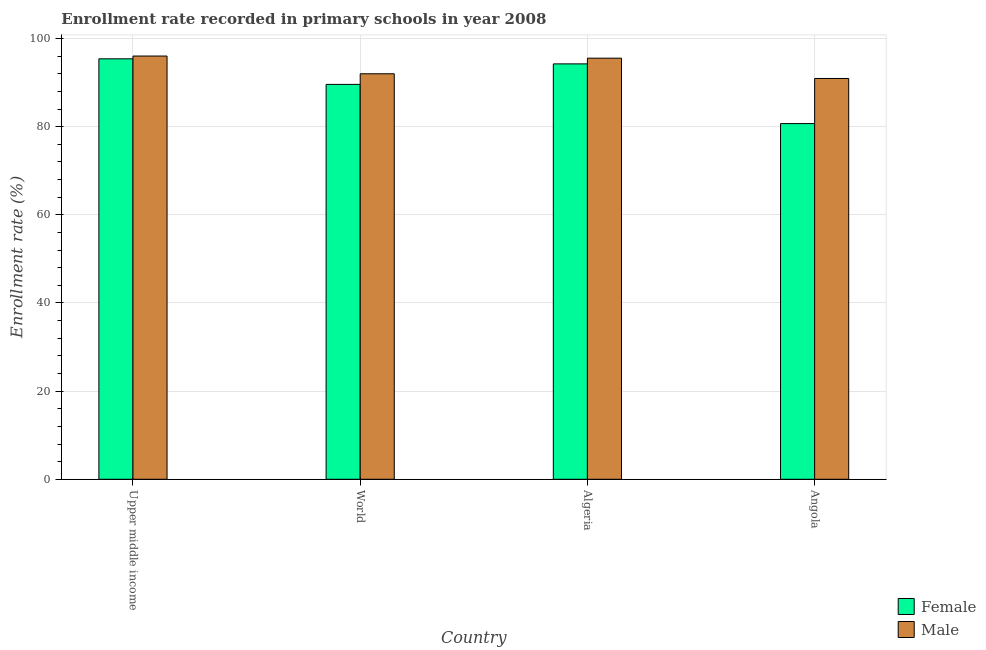How many different coloured bars are there?
Ensure brevity in your answer.  2. How many bars are there on the 2nd tick from the right?
Offer a very short reply. 2. What is the label of the 4th group of bars from the left?
Your response must be concise. Angola. In how many cases, is the number of bars for a given country not equal to the number of legend labels?
Make the answer very short. 0. What is the enrollment rate of male students in Upper middle income?
Your answer should be compact. 96.03. Across all countries, what is the maximum enrollment rate of male students?
Offer a terse response. 96.03. Across all countries, what is the minimum enrollment rate of male students?
Your response must be concise. 90.94. In which country was the enrollment rate of male students maximum?
Provide a short and direct response. Upper middle income. In which country was the enrollment rate of male students minimum?
Provide a short and direct response. Angola. What is the total enrollment rate of male students in the graph?
Offer a terse response. 374.51. What is the difference between the enrollment rate of male students in Algeria and that in World?
Keep it short and to the point. 3.54. What is the difference between the enrollment rate of male students in Algeria and the enrollment rate of female students in World?
Give a very brief answer. 5.95. What is the average enrollment rate of female students per country?
Keep it short and to the point. 89.98. What is the difference between the enrollment rate of male students and enrollment rate of female students in Algeria?
Your answer should be very brief. 1.3. In how many countries, is the enrollment rate of male students greater than 40 %?
Make the answer very short. 4. What is the ratio of the enrollment rate of male students in Algeria to that in World?
Your answer should be very brief. 1.04. Is the difference between the enrollment rate of female students in Algeria and Angola greater than the difference between the enrollment rate of male students in Algeria and Angola?
Offer a terse response. Yes. What is the difference between the highest and the second highest enrollment rate of male students?
Your response must be concise. 0.48. What is the difference between the highest and the lowest enrollment rate of female students?
Your response must be concise. 14.7. Is the sum of the enrollment rate of female students in Algeria and Angola greater than the maximum enrollment rate of male students across all countries?
Keep it short and to the point. Yes. What does the 2nd bar from the right in Angola represents?
Ensure brevity in your answer.  Female. Are all the bars in the graph horizontal?
Ensure brevity in your answer.  No. What is the difference between two consecutive major ticks on the Y-axis?
Provide a short and direct response. 20. Does the graph contain grids?
Give a very brief answer. Yes. How many legend labels are there?
Keep it short and to the point. 2. How are the legend labels stacked?
Ensure brevity in your answer.  Vertical. What is the title of the graph?
Provide a short and direct response. Enrollment rate recorded in primary schools in year 2008. What is the label or title of the Y-axis?
Provide a short and direct response. Enrollment rate (%). What is the Enrollment rate (%) of Female in Upper middle income?
Offer a terse response. 95.4. What is the Enrollment rate (%) in Male in Upper middle income?
Provide a succinct answer. 96.03. What is the Enrollment rate (%) of Female in World?
Your answer should be compact. 89.59. What is the Enrollment rate (%) of Male in World?
Provide a short and direct response. 92. What is the Enrollment rate (%) of Female in Algeria?
Make the answer very short. 94.25. What is the Enrollment rate (%) in Male in Algeria?
Offer a terse response. 95.54. What is the Enrollment rate (%) of Female in Angola?
Your response must be concise. 80.7. What is the Enrollment rate (%) in Male in Angola?
Provide a short and direct response. 90.94. Across all countries, what is the maximum Enrollment rate (%) of Female?
Provide a short and direct response. 95.4. Across all countries, what is the maximum Enrollment rate (%) of Male?
Your answer should be compact. 96.03. Across all countries, what is the minimum Enrollment rate (%) in Female?
Your response must be concise. 80.7. Across all countries, what is the minimum Enrollment rate (%) of Male?
Keep it short and to the point. 90.94. What is the total Enrollment rate (%) in Female in the graph?
Give a very brief answer. 359.94. What is the total Enrollment rate (%) of Male in the graph?
Provide a short and direct response. 374.51. What is the difference between the Enrollment rate (%) in Female in Upper middle income and that in World?
Make the answer very short. 5.81. What is the difference between the Enrollment rate (%) of Male in Upper middle income and that in World?
Provide a short and direct response. 4.03. What is the difference between the Enrollment rate (%) of Female in Upper middle income and that in Algeria?
Offer a very short reply. 1.15. What is the difference between the Enrollment rate (%) of Male in Upper middle income and that in Algeria?
Provide a succinct answer. 0.48. What is the difference between the Enrollment rate (%) in Female in Upper middle income and that in Angola?
Provide a short and direct response. 14.7. What is the difference between the Enrollment rate (%) in Male in Upper middle income and that in Angola?
Your answer should be compact. 5.09. What is the difference between the Enrollment rate (%) in Female in World and that in Algeria?
Your response must be concise. -4.66. What is the difference between the Enrollment rate (%) of Male in World and that in Algeria?
Your answer should be very brief. -3.54. What is the difference between the Enrollment rate (%) in Female in World and that in Angola?
Offer a terse response. 8.89. What is the difference between the Enrollment rate (%) of Male in World and that in Angola?
Your answer should be compact. 1.07. What is the difference between the Enrollment rate (%) in Female in Algeria and that in Angola?
Ensure brevity in your answer.  13.54. What is the difference between the Enrollment rate (%) in Male in Algeria and that in Angola?
Ensure brevity in your answer.  4.61. What is the difference between the Enrollment rate (%) of Female in Upper middle income and the Enrollment rate (%) of Male in World?
Make the answer very short. 3.4. What is the difference between the Enrollment rate (%) in Female in Upper middle income and the Enrollment rate (%) in Male in Algeria?
Provide a succinct answer. -0.15. What is the difference between the Enrollment rate (%) in Female in Upper middle income and the Enrollment rate (%) in Male in Angola?
Make the answer very short. 4.46. What is the difference between the Enrollment rate (%) in Female in World and the Enrollment rate (%) in Male in Algeria?
Provide a short and direct response. -5.95. What is the difference between the Enrollment rate (%) in Female in World and the Enrollment rate (%) in Male in Angola?
Your response must be concise. -1.35. What is the difference between the Enrollment rate (%) in Female in Algeria and the Enrollment rate (%) in Male in Angola?
Make the answer very short. 3.31. What is the average Enrollment rate (%) of Female per country?
Your answer should be compact. 89.98. What is the average Enrollment rate (%) in Male per country?
Give a very brief answer. 93.63. What is the difference between the Enrollment rate (%) of Female and Enrollment rate (%) of Male in Upper middle income?
Make the answer very short. -0.63. What is the difference between the Enrollment rate (%) of Female and Enrollment rate (%) of Male in World?
Offer a terse response. -2.41. What is the difference between the Enrollment rate (%) in Female and Enrollment rate (%) in Male in Algeria?
Offer a very short reply. -1.3. What is the difference between the Enrollment rate (%) of Female and Enrollment rate (%) of Male in Angola?
Provide a short and direct response. -10.23. What is the ratio of the Enrollment rate (%) in Female in Upper middle income to that in World?
Provide a succinct answer. 1.06. What is the ratio of the Enrollment rate (%) of Male in Upper middle income to that in World?
Offer a terse response. 1.04. What is the ratio of the Enrollment rate (%) in Female in Upper middle income to that in Algeria?
Keep it short and to the point. 1.01. What is the ratio of the Enrollment rate (%) of Female in Upper middle income to that in Angola?
Give a very brief answer. 1.18. What is the ratio of the Enrollment rate (%) in Male in Upper middle income to that in Angola?
Offer a terse response. 1.06. What is the ratio of the Enrollment rate (%) in Female in World to that in Algeria?
Make the answer very short. 0.95. What is the ratio of the Enrollment rate (%) in Male in World to that in Algeria?
Your answer should be very brief. 0.96. What is the ratio of the Enrollment rate (%) in Female in World to that in Angola?
Your response must be concise. 1.11. What is the ratio of the Enrollment rate (%) of Male in World to that in Angola?
Make the answer very short. 1.01. What is the ratio of the Enrollment rate (%) in Female in Algeria to that in Angola?
Make the answer very short. 1.17. What is the ratio of the Enrollment rate (%) of Male in Algeria to that in Angola?
Offer a terse response. 1.05. What is the difference between the highest and the second highest Enrollment rate (%) in Female?
Your answer should be very brief. 1.15. What is the difference between the highest and the second highest Enrollment rate (%) of Male?
Keep it short and to the point. 0.48. What is the difference between the highest and the lowest Enrollment rate (%) in Female?
Your response must be concise. 14.7. What is the difference between the highest and the lowest Enrollment rate (%) of Male?
Offer a very short reply. 5.09. 